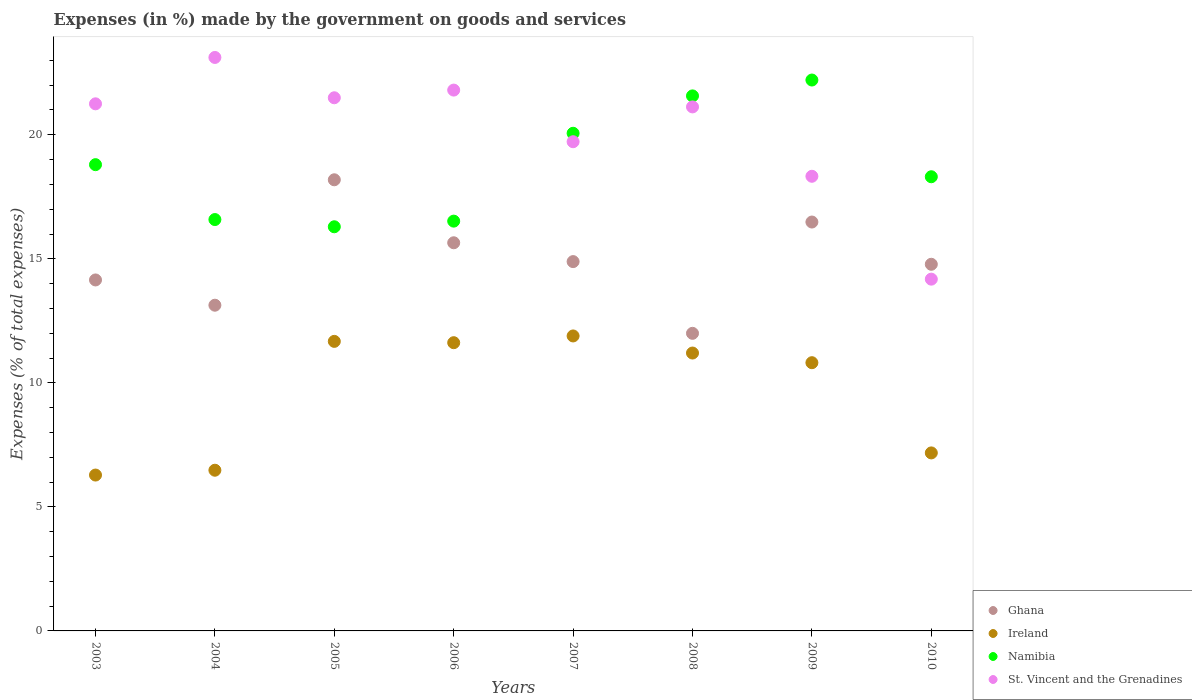How many different coloured dotlines are there?
Keep it short and to the point. 4. What is the percentage of expenses made by the government on goods and services in Namibia in 2007?
Provide a succinct answer. 20.06. Across all years, what is the maximum percentage of expenses made by the government on goods and services in Ireland?
Keep it short and to the point. 11.89. Across all years, what is the minimum percentage of expenses made by the government on goods and services in Ghana?
Make the answer very short. 12. In which year was the percentage of expenses made by the government on goods and services in Namibia maximum?
Your answer should be very brief. 2009. In which year was the percentage of expenses made by the government on goods and services in St. Vincent and the Grenadines minimum?
Offer a very short reply. 2010. What is the total percentage of expenses made by the government on goods and services in St. Vincent and the Grenadines in the graph?
Give a very brief answer. 161.01. What is the difference between the percentage of expenses made by the government on goods and services in Ghana in 2008 and that in 2009?
Provide a succinct answer. -4.49. What is the difference between the percentage of expenses made by the government on goods and services in Namibia in 2003 and the percentage of expenses made by the government on goods and services in Ireland in 2007?
Your answer should be compact. 6.9. What is the average percentage of expenses made by the government on goods and services in Ireland per year?
Offer a very short reply. 9.64. In the year 2008, what is the difference between the percentage of expenses made by the government on goods and services in Ireland and percentage of expenses made by the government on goods and services in Ghana?
Give a very brief answer. -0.79. What is the ratio of the percentage of expenses made by the government on goods and services in Ireland in 2004 to that in 2009?
Offer a very short reply. 0.6. Is the difference between the percentage of expenses made by the government on goods and services in Ireland in 2004 and 2007 greater than the difference between the percentage of expenses made by the government on goods and services in Ghana in 2004 and 2007?
Your answer should be compact. No. What is the difference between the highest and the second highest percentage of expenses made by the government on goods and services in Ghana?
Your answer should be very brief. 1.7. What is the difference between the highest and the lowest percentage of expenses made by the government on goods and services in Ghana?
Provide a succinct answer. 6.19. How many dotlines are there?
Your response must be concise. 4. How many years are there in the graph?
Ensure brevity in your answer.  8. Are the values on the major ticks of Y-axis written in scientific E-notation?
Ensure brevity in your answer.  No. Does the graph contain any zero values?
Offer a very short reply. No. Does the graph contain grids?
Your answer should be very brief. No. How many legend labels are there?
Keep it short and to the point. 4. What is the title of the graph?
Your answer should be very brief. Expenses (in %) made by the government on goods and services. What is the label or title of the Y-axis?
Provide a short and direct response. Expenses (% of total expenses). What is the Expenses (% of total expenses) of Ghana in 2003?
Offer a very short reply. 14.15. What is the Expenses (% of total expenses) of Ireland in 2003?
Your answer should be compact. 6.28. What is the Expenses (% of total expenses) in Namibia in 2003?
Your response must be concise. 18.8. What is the Expenses (% of total expenses) of St. Vincent and the Grenadines in 2003?
Provide a succinct answer. 21.25. What is the Expenses (% of total expenses) in Ghana in 2004?
Provide a short and direct response. 13.13. What is the Expenses (% of total expenses) in Ireland in 2004?
Give a very brief answer. 6.48. What is the Expenses (% of total expenses) in Namibia in 2004?
Your response must be concise. 16.58. What is the Expenses (% of total expenses) of St. Vincent and the Grenadines in 2004?
Offer a very short reply. 23.12. What is the Expenses (% of total expenses) in Ghana in 2005?
Offer a terse response. 18.19. What is the Expenses (% of total expenses) in Ireland in 2005?
Make the answer very short. 11.67. What is the Expenses (% of total expenses) of Namibia in 2005?
Your answer should be compact. 16.29. What is the Expenses (% of total expenses) of St. Vincent and the Grenadines in 2005?
Make the answer very short. 21.49. What is the Expenses (% of total expenses) of Ghana in 2006?
Offer a terse response. 15.65. What is the Expenses (% of total expenses) in Ireland in 2006?
Provide a succinct answer. 11.62. What is the Expenses (% of total expenses) in Namibia in 2006?
Your answer should be compact. 16.52. What is the Expenses (% of total expenses) of St. Vincent and the Grenadines in 2006?
Your answer should be very brief. 21.8. What is the Expenses (% of total expenses) of Ghana in 2007?
Make the answer very short. 14.89. What is the Expenses (% of total expenses) in Ireland in 2007?
Your answer should be very brief. 11.89. What is the Expenses (% of total expenses) of Namibia in 2007?
Keep it short and to the point. 20.06. What is the Expenses (% of total expenses) in St. Vincent and the Grenadines in 2007?
Offer a very short reply. 19.72. What is the Expenses (% of total expenses) of Ghana in 2008?
Your response must be concise. 12. What is the Expenses (% of total expenses) of Ireland in 2008?
Your answer should be compact. 11.2. What is the Expenses (% of total expenses) in Namibia in 2008?
Your response must be concise. 21.57. What is the Expenses (% of total expenses) of St. Vincent and the Grenadines in 2008?
Offer a very short reply. 21.12. What is the Expenses (% of total expenses) in Ghana in 2009?
Give a very brief answer. 16.48. What is the Expenses (% of total expenses) of Ireland in 2009?
Your response must be concise. 10.81. What is the Expenses (% of total expenses) of Namibia in 2009?
Your response must be concise. 22.21. What is the Expenses (% of total expenses) in St. Vincent and the Grenadines in 2009?
Your response must be concise. 18.33. What is the Expenses (% of total expenses) in Ghana in 2010?
Offer a very short reply. 14.78. What is the Expenses (% of total expenses) of Ireland in 2010?
Provide a short and direct response. 7.18. What is the Expenses (% of total expenses) of Namibia in 2010?
Your answer should be very brief. 18.31. What is the Expenses (% of total expenses) in St. Vincent and the Grenadines in 2010?
Your answer should be very brief. 14.18. Across all years, what is the maximum Expenses (% of total expenses) in Ghana?
Your response must be concise. 18.19. Across all years, what is the maximum Expenses (% of total expenses) in Ireland?
Give a very brief answer. 11.89. Across all years, what is the maximum Expenses (% of total expenses) in Namibia?
Make the answer very short. 22.21. Across all years, what is the maximum Expenses (% of total expenses) of St. Vincent and the Grenadines?
Your answer should be very brief. 23.12. Across all years, what is the minimum Expenses (% of total expenses) in Ghana?
Offer a terse response. 12. Across all years, what is the minimum Expenses (% of total expenses) of Ireland?
Offer a terse response. 6.28. Across all years, what is the minimum Expenses (% of total expenses) of Namibia?
Give a very brief answer. 16.29. Across all years, what is the minimum Expenses (% of total expenses) in St. Vincent and the Grenadines?
Your response must be concise. 14.18. What is the total Expenses (% of total expenses) in Ghana in the graph?
Ensure brevity in your answer.  119.26. What is the total Expenses (% of total expenses) of Ireland in the graph?
Provide a short and direct response. 77.13. What is the total Expenses (% of total expenses) of Namibia in the graph?
Provide a succinct answer. 150.33. What is the total Expenses (% of total expenses) in St. Vincent and the Grenadines in the graph?
Your response must be concise. 161.01. What is the difference between the Expenses (% of total expenses) of Ghana in 2003 and that in 2004?
Provide a succinct answer. 1.02. What is the difference between the Expenses (% of total expenses) of Ireland in 2003 and that in 2004?
Your answer should be compact. -0.19. What is the difference between the Expenses (% of total expenses) of Namibia in 2003 and that in 2004?
Give a very brief answer. 2.21. What is the difference between the Expenses (% of total expenses) of St. Vincent and the Grenadines in 2003 and that in 2004?
Your answer should be very brief. -1.87. What is the difference between the Expenses (% of total expenses) of Ghana in 2003 and that in 2005?
Make the answer very short. -4.04. What is the difference between the Expenses (% of total expenses) of Ireland in 2003 and that in 2005?
Provide a succinct answer. -5.39. What is the difference between the Expenses (% of total expenses) in Namibia in 2003 and that in 2005?
Offer a very short reply. 2.5. What is the difference between the Expenses (% of total expenses) of St. Vincent and the Grenadines in 2003 and that in 2005?
Your response must be concise. -0.24. What is the difference between the Expenses (% of total expenses) of Ghana in 2003 and that in 2006?
Offer a terse response. -1.5. What is the difference between the Expenses (% of total expenses) in Ireland in 2003 and that in 2006?
Ensure brevity in your answer.  -5.34. What is the difference between the Expenses (% of total expenses) in Namibia in 2003 and that in 2006?
Your response must be concise. 2.28. What is the difference between the Expenses (% of total expenses) in St. Vincent and the Grenadines in 2003 and that in 2006?
Offer a very short reply. -0.55. What is the difference between the Expenses (% of total expenses) of Ghana in 2003 and that in 2007?
Give a very brief answer. -0.74. What is the difference between the Expenses (% of total expenses) in Ireland in 2003 and that in 2007?
Give a very brief answer. -5.61. What is the difference between the Expenses (% of total expenses) in Namibia in 2003 and that in 2007?
Your response must be concise. -1.27. What is the difference between the Expenses (% of total expenses) of St. Vincent and the Grenadines in 2003 and that in 2007?
Your response must be concise. 1.53. What is the difference between the Expenses (% of total expenses) in Ghana in 2003 and that in 2008?
Provide a succinct answer. 2.15. What is the difference between the Expenses (% of total expenses) of Ireland in 2003 and that in 2008?
Offer a terse response. -4.92. What is the difference between the Expenses (% of total expenses) in Namibia in 2003 and that in 2008?
Your response must be concise. -2.77. What is the difference between the Expenses (% of total expenses) of St. Vincent and the Grenadines in 2003 and that in 2008?
Give a very brief answer. 0.12. What is the difference between the Expenses (% of total expenses) of Ghana in 2003 and that in 2009?
Provide a short and direct response. -2.33. What is the difference between the Expenses (% of total expenses) in Ireland in 2003 and that in 2009?
Keep it short and to the point. -4.53. What is the difference between the Expenses (% of total expenses) of Namibia in 2003 and that in 2009?
Your answer should be compact. -3.41. What is the difference between the Expenses (% of total expenses) of St. Vincent and the Grenadines in 2003 and that in 2009?
Offer a very short reply. 2.92. What is the difference between the Expenses (% of total expenses) of Ghana in 2003 and that in 2010?
Make the answer very short. -0.63. What is the difference between the Expenses (% of total expenses) of Ireland in 2003 and that in 2010?
Your answer should be compact. -0.89. What is the difference between the Expenses (% of total expenses) of Namibia in 2003 and that in 2010?
Provide a succinct answer. 0.49. What is the difference between the Expenses (% of total expenses) of St. Vincent and the Grenadines in 2003 and that in 2010?
Give a very brief answer. 7.07. What is the difference between the Expenses (% of total expenses) of Ghana in 2004 and that in 2005?
Give a very brief answer. -5.06. What is the difference between the Expenses (% of total expenses) in Ireland in 2004 and that in 2005?
Offer a terse response. -5.19. What is the difference between the Expenses (% of total expenses) of Namibia in 2004 and that in 2005?
Offer a terse response. 0.29. What is the difference between the Expenses (% of total expenses) of St. Vincent and the Grenadines in 2004 and that in 2005?
Offer a terse response. 1.63. What is the difference between the Expenses (% of total expenses) of Ghana in 2004 and that in 2006?
Make the answer very short. -2.52. What is the difference between the Expenses (% of total expenses) in Ireland in 2004 and that in 2006?
Provide a short and direct response. -5.14. What is the difference between the Expenses (% of total expenses) in Namibia in 2004 and that in 2006?
Provide a succinct answer. 0.06. What is the difference between the Expenses (% of total expenses) in St. Vincent and the Grenadines in 2004 and that in 2006?
Ensure brevity in your answer.  1.32. What is the difference between the Expenses (% of total expenses) of Ghana in 2004 and that in 2007?
Ensure brevity in your answer.  -1.76. What is the difference between the Expenses (% of total expenses) in Ireland in 2004 and that in 2007?
Make the answer very short. -5.41. What is the difference between the Expenses (% of total expenses) in Namibia in 2004 and that in 2007?
Keep it short and to the point. -3.48. What is the difference between the Expenses (% of total expenses) in St. Vincent and the Grenadines in 2004 and that in 2007?
Your response must be concise. 3.4. What is the difference between the Expenses (% of total expenses) of Ghana in 2004 and that in 2008?
Your response must be concise. 1.13. What is the difference between the Expenses (% of total expenses) in Ireland in 2004 and that in 2008?
Give a very brief answer. -4.72. What is the difference between the Expenses (% of total expenses) of Namibia in 2004 and that in 2008?
Keep it short and to the point. -4.98. What is the difference between the Expenses (% of total expenses) of St. Vincent and the Grenadines in 2004 and that in 2008?
Offer a very short reply. 1.99. What is the difference between the Expenses (% of total expenses) in Ghana in 2004 and that in 2009?
Provide a succinct answer. -3.35. What is the difference between the Expenses (% of total expenses) in Ireland in 2004 and that in 2009?
Make the answer very short. -4.33. What is the difference between the Expenses (% of total expenses) of Namibia in 2004 and that in 2009?
Give a very brief answer. -5.62. What is the difference between the Expenses (% of total expenses) in St. Vincent and the Grenadines in 2004 and that in 2009?
Your response must be concise. 4.79. What is the difference between the Expenses (% of total expenses) of Ghana in 2004 and that in 2010?
Give a very brief answer. -1.65. What is the difference between the Expenses (% of total expenses) of Ireland in 2004 and that in 2010?
Your answer should be compact. -0.7. What is the difference between the Expenses (% of total expenses) in Namibia in 2004 and that in 2010?
Give a very brief answer. -1.73. What is the difference between the Expenses (% of total expenses) in St. Vincent and the Grenadines in 2004 and that in 2010?
Make the answer very short. 8.94. What is the difference between the Expenses (% of total expenses) in Ghana in 2005 and that in 2006?
Give a very brief answer. 2.54. What is the difference between the Expenses (% of total expenses) in Ireland in 2005 and that in 2006?
Provide a succinct answer. 0.05. What is the difference between the Expenses (% of total expenses) of Namibia in 2005 and that in 2006?
Make the answer very short. -0.23. What is the difference between the Expenses (% of total expenses) in St. Vincent and the Grenadines in 2005 and that in 2006?
Offer a very short reply. -0.31. What is the difference between the Expenses (% of total expenses) in Ghana in 2005 and that in 2007?
Your answer should be compact. 3.3. What is the difference between the Expenses (% of total expenses) in Ireland in 2005 and that in 2007?
Make the answer very short. -0.22. What is the difference between the Expenses (% of total expenses) of Namibia in 2005 and that in 2007?
Your answer should be compact. -3.77. What is the difference between the Expenses (% of total expenses) in St. Vincent and the Grenadines in 2005 and that in 2007?
Your answer should be very brief. 1.77. What is the difference between the Expenses (% of total expenses) in Ghana in 2005 and that in 2008?
Offer a terse response. 6.19. What is the difference between the Expenses (% of total expenses) in Ireland in 2005 and that in 2008?
Your answer should be very brief. 0.47. What is the difference between the Expenses (% of total expenses) of Namibia in 2005 and that in 2008?
Your answer should be compact. -5.28. What is the difference between the Expenses (% of total expenses) of St. Vincent and the Grenadines in 2005 and that in 2008?
Your answer should be very brief. 0.37. What is the difference between the Expenses (% of total expenses) of Ghana in 2005 and that in 2009?
Offer a very short reply. 1.7. What is the difference between the Expenses (% of total expenses) in Ireland in 2005 and that in 2009?
Ensure brevity in your answer.  0.86. What is the difference between the Expenses (% of total expenses) in Namibia in 2005 and that in 2009?
Offer a terse response. -5.92. What is the difference between the Expenses (% of total expenses) of St. Vincent and the Grenadines in 2005 and that in 2009?
Offer a terse response. 3.17. What is the difference between the Expenses (% of total expenses) in Ghana in 2005 and that in 2010?
Provide a succinct answer. 3.41. What is the difference between the Expenses (% of total expenses) of Ireland in 2005 and that in 2010?
Keep it short and to the point. 4.5. What is the difference between the Expenses (% of total expenses) in Namibia in 2005 and that in 2010?
Give a very brief answer. -2.02. What is the difference between the Expenses (% of total expenses) of St. Vincent and the Grenadines in 2005 and that in 2010?
Your answer should be very brief. 7.31. What is the difference between the Expenses (% of total expenses) of Ghana in 2006 and that in 2007?
Your answer should be compact. 0.76. What is the difference between the Expenses (% of total expenses) of Ireland in 2006 and that in 2007?
Your answer should be very brief. -0.27. What is the difference between the Expenses (% of total expenses) of Namibia in 2006 and that in 2007?
Your answer should be compact. -3.54. What is the difference between the Expenses (% of total expenses) in St. Vincent and the Grenadines in 2006 and that in 2007?
Give a very brief answer. 2.08. What is the difference between the Expenses (% of total expenses) in Ghana in 2006 and that in 2008?
Your answer should be very brief. 3.65. What is the difference between the Expenses (% of total expenses) of Ireland in 2006 and that in 2008?
Your answer should be very brief. 0.42. What is the difference between the Expenses (% of total expenses) in Namibia in 2006 and that in 2008?
Provide a succinct answer. -5.05. What is the difference between the Expenses (% of total expenses) in St. Vincent and the Grenadines in 2006 and that in 2008?
Your response must be concise. 0.68. What is the difference between the Expenses (% of total expenses) in Ghana in 2006 and that in 2009?
Ensure brevity in your answer.  -0.84. What is the difference between the Expenses (% of total expenses) in Ireland in 2006 and that in 2009?
Provide a short and direct response. 0.81. What is the difference between the Expenses (% of total expenses) in Namibia in 2006 and that in 2009?
Keep it short and to the point. -5.69. What is the difference between the Expenses (% of total expenses) of St. Vincent and the Grenadines in 2006 and that in 2009?
Keep it short and to the point. 3.47. What is the difference between the Expenses (% of total expenses) in Ghana in 2006 and that in 2010?
Keep it short and to the point. 0.87. What is the difference between the Expenses (% of total expenses) in Ireland in 2006 and that in 2010?
Give a very brief answer. 4.44. What is the difference between the Expenses (% of total expenses) of Namibia in 2006 and that in 2010?
Your response must be concise. -1.79. What is the difference between the Expenses (% of total expenses) in St. Vincent and the Grenadines in 2006 and that in 2010?
Give a very brief answer. 7.62. What is the difference between the Expenses (% of total expenses) in Ghana in 2007 and that in 2008?
Make the answer very short. 2.89. What is the difference between the Expenses (% of total expenses) in Ireland in 2007 and that in 2008?
Your answer should be very brief. 0.69. What is the difference between the Expenses (% of total expenses) of Namibia in 2007 and that in 2008?
Your response must be concise. -1.51. What is the difference between the Expenses (% of total expenses) of St. Vincent and the Grenadines in 2007 and that in 2008?
Provide a short and direct response. -1.4. What is the difference between the Expenses (% of total expenses) in Ghana in 2007 and that in 2009?
Give a very brief answer. -1.6. What is the difference between the Expenses (% of total expenses) of Ireland in 2007 and that in 2009?
Ensure brevity in your answer.  1.08. What is the difference between the Expenses (% of total expenses) of Namibia in 2007 and that in 2009?
Your response must be concise. -2.15. What is the difference between the Expenses (% of total expenses) in St. Vincent and the Grenadines in 2007 and that in 2009?
Make the answer very short. 1.39. What is the difference between the Expenses (% of total expenses) in Ghana in 2007 and that in 2010?
Offer a very short reply. 0.11. What is the difference between the Expenses (% of total expenses) of Ireland in 2007 and that in 2010?
Offer a very short reply. 4.71. What is the difference between the Expenses (% of total expenses) in Namibia in 2007 and that in 2010?
Provide a short and direct response. 1.75. What is the difference between the Expenses (% of total expenses) of St. Vincent and the Grenadines in 2007 and that in 2010?
Your response must be concise. 5.54. What is the difference between the Expenses (% of total expenses) in Ghana in 2008 and that in 2009?
Your answer should be compact. -4.49. What is the difference between the Expenses (% of total expenses) of Ireland in 2008 and that in 2009?
Give a very brief answer. 0.39. What is the difference between the Expenses (% of total expenses) in Namibia in 2008 and that in 2009?
Make the answer very short. -0.64. What is the difference between the Expenses (% of total expenses) in St. Vincent and the Grenadines in 2008 and that in 2009?
Provide a short and direct response. 2.8. What is the difference between the Expenses (% of total expenses) in Ghana in 2008 and that in 2010?
Provide a succinct answer. -2.78. What is the difference between the Expenses (% of total expenses) in Ireland in 2008 and that in 2010?
Your answer should be very brief. 4.03. What is the difference between the Expenses (% of total expenses) in Namibia in 2008 and that in 2010?
Make the answer very short. 3.26. What is the difference between the Expenses (% of total expenses) in St. Vincent and the Grenadines in 2008 and that in 2010?
Keep it short and to the point. 6.94. What is the difference between the Expenses (% of total expenses) in Ghana in 2009 and that in 2010?
Offer a very short reply. 1.7. What is the difference between the Expenses (% of total expenses) of Ireland in 2009 and that in 2010?
Provide a short and direct response. 3.64. What is the difference between the Expenses (% of total expenses) of Namibia in 2009 and that in 2010?
Offer a very short reply. 3.9. What is the difference between the Expenses (% of total expenses) in St. Vincent and the Grenadines in 2009 and that in 2010?
Provide a succinct answer. 4.15. What is the difference between the Expenses (% of total expenses) in Ghana in 2003 and the Expenses (% of total expenses) in Ireland in 2004?
Your answer should be very brief. 7.67. What is the difference between the Expenses (% of total expenses) of Ghana in 2003 and the Expenses (% of total expenses) of Namibia in 2004?
Provide a succinct answer. -2.43. What is the difference between the Expenses (% of total expenses) of Ghana in 2003 and the Expenses (% of total expenses) of St. Vincent and the Grenadines in 2004?
Your answer should be compact. -8.97. What is the difference between the Expenses (% of total expenses) of Ireland in 2003 and the Expenses (% of total expenses) of Namibia in 2004?
Offer a very short reply. -10.3. What is the difference between the Expenses (% of total expenses) of Ireland in 2003 and the Expenses (% of total expenses) of St. Vincent and the Grenadines in 2004?
Keep it short and to the point. -16.83. What is the difference between the Expenses (% of total expenses) in Namibia in 2003 and the Expenses (% of total expenses) in St. Vincent and the Grenadines in 2004?
Offer a very short reply. -4.32. What is the difference between the Expenses (% of total expenses) of Ghana in 2003 and the Expenses (% of total expenses) of Ireland in 2005?
Give a very brief answer. 2.48. What is the difference between the Expenses (% of total expenses) of Ghana in 2003 and the Expenses (% of total expenses) of Namibia in 2005?
Keep it short and to the point. -2.14. What is the difference between the Expenses (% of total expenses) of Ghana in 2003 and the Expenses (% of total expenses) of St. Vincent and the Grenadines in 2005?
Your answer should be compact. -7.34. What is the difference between the Expenses (% of total expenses) of Ireland in 2003 and the Expenses (% of total expenses) of Namibia in 2005?
Ensure brevity in your answer.  -10.01. What is the difference between the Expenses (% of total expenses) in Ireland in 2003 and the Expenses (% of total expenses) in St. Vincent and the Grenadines in 2005?
Make the answer very short. -15.21. What is the difference between the Expenses (% of total expenses) in Namibia in 2003 and the Expenses (% of total expenses) in St. Vincent and the Grenadines in 2005?
Your response must be concise. -2.7. What is the difference between the Expenses (% of total expenses) in Ghana in 2003 and the Expenses (% of total expenses) in Ireland in 2006?
Give a very brief answer. 2.53. What is the difference between the Expenses (% of total expenses) of Ghana in 2003 and the Expenses (% of total expenses) of Namibia in 2006?
Your answer should be very brief. -2.37. What is the difference between the Expenses (% of total expenses) in Ghana in 2003 and the Expenses (% of total expenses) in St. Vincent and the Grenadines in 2006?
Your answer should be very brief. -7.65. What is the difference between the Expenses (% of total expenses) of Ireland in 2003 and the Expenses (% of total expenses) of Namibia in 2006?
Ensure brevity in your answer.  -10.24. What is the difference between the Expenses (% of total expenses) in Ireland in 2003 and the Expenses (% of total expenses) in St. Vincent and the Grenadines in 2006?
Make the answer very short. -15.52. What is the difference between the Expenses (% of total expenses) in Namibia in 2003 and the Expenses (% of total expenses) in St. Vincent and the Grenadines in 2006?
Provide a short and direct response. -3.01. What is the difference between the Expenses (% of total expenses) in Ghana in 2003 and the Expenses (% of total expenses) in Ireland in 2007?
Your answer should be compact. 2.26. What is the difference between the Expenses (% of total expenses) of Ghana in 2003 and the Expenses (% of total expenses) of Namibia in 2007?
Your response must be concise. -5.91. What is the difference between the Expenses (% of total expenses) in Ghana in 2003 and the Expenses (% of total expenses) in St. Vincent and the Grenadines in 2007?
Your answer should be compact. -5.57. What is the difference between the Expenses (% of total expenses) in Ireland in 2003 and the Expenses (% of total expenses) in Namibia in 2007?
Offer a very short reply. -13.78. What is the difference between the Expenses (% of total expenses) in Ireland in 2003 and the Expenses (% of total expenses) in St. Vincent and the Grenadines in 2007?
Give a very brief answer. -13.44. What is the difference between the Expenses (% of total expenses) in Namibia in 2003 and the Expenses (% of total expenses) in St. Vincent and the Grenadines in 2007?
Keep it short and to the point. -0.92. What is the difference between the Expenses (% of total expenses) in Ghana in 2003 and the Expenses (% of total expenses) in Ireland in 2008?
Your response must be concise. 2.95. What is the difference between the Expenses (% of total expenses) of Ghana in 2003 and the Expenses (% of total expenses) of Namibia in 2008?
Offer a very short reply. -7.42. What is the difference between the Expenses (% of total expenses) of Ghana in 2003 and the Expenses (% of total expenses) of St. Vincent and the Grenadines in 2008?
Provide a succinct answer. -6.98. What is the difference between the Expenses (% of total expenses) of Ireland in 2003 and the Expenses (% of total expenses) of Namibia in 2008?
Offer a very short reply. -15.28. What is the difference between the Expenses (% of total expenses) in Ireland in 2003 and the Expenses (% of total expenses) in St. Vincent and the Grenadines in 2008?
Ensure brevity in your answer.  -14.84. What is the difference between the Expenses (% of total expenses) of Namibia in 2003 and the Expenses (% of total expenses) of St. Vincent and the Grenadines in 2008?
Offer a terse response. -2.33. What is the difference between the Expenses (% of total expenses) in Ghana in 2003 and the Expenses (% of total expenses) in Ireland in 2009?
Keep it short and to the point. 3.34. What is the difference between the Expenses (% of total expenses) of Ghana in 2003 and the Expenses (% of total expenses) of Namibia in 2009?
Ensure brevity in your answer.  -8.06. What is the difference between the Expenses (% of total expenses) in Ghana in 2003 and the Expenses (% of total expenses) in St. Vincent and the Grenadines in 2009?
Your response must be concise. -4.18. What is the difference between the Expenses (% of total expenses) of Ireland in 2003 and the Expenses (% of total expenses) of Namibia in 2009?
Your response must be concise. -15.92. What is the difference between the Expenses (% of total expenses) of Ireland in 2003 and the Expenses (% of total expenses) of St. Vincent and the Grenadines in 2009?
Offer a terse response. -12.04. What is the difference between the Expenses (% of total expenses) of Namibia in 2003 and the Expenses (% of total expenses) of St. Vincent and the Grenadines in 2009?
Your answer should be compact. 0.47. What is the difference between the Expenses (% of total expenses) in Ghana in 2003 and the Expenses (% of total expenses) in Ireland in 2010?
Make the answer very short. 6.97. What is the difference between the Expenses (% of total expenses) of Ghana in 2003 and the Expenses (% of total expenses) of Namibia in 2010?
Ensure brevity in your answer.  -4.16. What is the difference between the Expenses (% of total expenses) in Ghana in 2003 and the Expenses (% of total expenses) in St. Vincent and the Grenadines in 2010?
Your response must be concise. -0.03. What is the difference between the Expenses (% of total expenses) in Ireland in 2003 and the Expenses (% of total expenses) in Namibia in 2010?
Make the answer very short. -12.02. What is the difference between the Expenses (% of total expenses) of Ireland in 2003 and the Expenses (% of total expenses) of St. Vincent and the Grenadines in 2010?
Provide a succinct answer. -7.9. What is the difference between the Expenses (% of total expenses) of Namibia in 2003 and the Expenses (% of total expenses) of St. Vincent and the Grenadines in 2010?
Give a very brief answer. 4.62. What is the difference between the Expenses (% of total expenses) of Ghana in 2004 and the Expenses (% of total expenses) of Ireland in 2005?
Your response must be concise. 1.46. What is the difference between the Expenses (% of total expenses) of Ghana in 2004 and the Expenses (% of total expenses) of Namibia in 2005?
Your answer should be compact. -3.16. What is the difference between the Expenses (% of total expenses) of Ghana in 2004 and the Expenses (% of total expenses) of St. Vincent and the Grenadines in 2005?
Your answer should be compact. -8.36. What is the difference between the Expenses (% of total expenses) in Ireland in 2004 and the Expenses (% of total expenses) in Namibia in 2005?
Ensure brevity in your answer.  -9.81. What is the difference between the Expenses (% of total expenses) in Ireland in 2004 and the Expenses (% of total expenses) in St. Vincent and the Grenadines in 2005?
Your answer should be compact. -15.01. What is the difference between the Expenses (% of total expenses) in Namibia in 2004 and the Expenses (% of total expenses) in St. Vincent and the Grenadines in 2005?
Your answer should be compact. -4.91. What is the difference between the Expenses (% of total expenses) in Ghana in 2004 and the Expenses (% of total expenses) in Ireland in 2006?
Ensure brevity in your answer.  1.51. What is the difference between the Expenses (% of total expenses) of Ghana in 2004 and the Expenses (% of total expenses) of Namibia in 2006?
Provide a short and direct response. -3.39. What is the difference between the Expenses (% of total expenses) in Ghana in 2004 and the Expenses (% of total expenses) in St. Vincent and the Grenadines in 2006?
Your answer should be compact. -8.67. What is the difference between the Expenses (% of total expenses) of Ireland in 2004 and the Expenses (% of total expenses) of Namibia in 2006?
Your response must be concise. -10.04. What is the difference between the Expenses (% of total expenses) in Ireland in 2004 and the Expenses (% of total expenses) in St. Vincent and the Grenadines in 2006?
Your answer should be very brief. -15.32. What is the difference between the Expenses (% of total expenses) in Namibia in 2004 and the Expenses (% of total expenses) in St. Vincent and the Grenadines in 2006?
Give a very brief answer. -5.22. What is the difference between the Expenses (% of total expenses) in Ghana in 2004 and the Expenses (% of total expenses) in Ireland in 2007?
Make the answer very short. 1.24. What is the difference between the Expenses (% of total expenses) of Ghana in 2004 and the Expenses (% of total expenses) of Namibia in 2007?
Offer a very short reply. -6.93. What is the difference between the Expenses (% of total expenses) of Ghana in 2004 and the Expenses (% of total expenses) of St. Vincent and the Grenadines in 2007?
Offer a very short reply. -6.59. What is the difference between the Expenses (% of total expenses) in Ireland in 2004 and the Expenses (% of total expenses) in Namibia in 2007?
Your answer should be compact. -13.58. What is the difference between the Expenses (% of total expenses) in Ireland in 2004 and the Expenses (% of total expenses) in St. Vincent and the Grenadines in 2007?
Keep it short and to the point. -13.24. What is the difference between the Expenses (% of total expenses) in Namibia in 2004 and the Expenses (% of total expenses) in St. Vincent and the Grenadines in 2007?
Your answer should be very brief. -3.14. What is the difference between the Expenses (% of total expenses) in Ghana in 2004 and the Expenses (% of total expenses) in Ireland in 2008?
Provide a succinct answer. 1.93. What is the difference between the Expenses (% of total expenses) in Ghana in 2004 and the Expenses (% of total expenses) in Namibia in 2008?
Ensure brevity in your answer.  -8.44. What is the difference between the Expenses (% of total expenses) in Ghana in 2004 and the Expenses (% of total expenses) in St. Vincent and the Grenadines in 2008?
Provide a succinct answer. -7.99. What is the difference between the Expenses (% of total expenses) of Ireland in 2004 and the Expenses (% of total expenses) of Namibia in 2008?
Your answer should be very brief. -15.09. What is the difference between the Expenses (% of total expenses) in Ireland in 2004 and the Expenses (% of total expenses) in St. Vincent and the Grenadines in 2008?
Ensure brevity in your answer.  -14.65. What is the difference between the Expenses (% of total expenses) of Namibia in 2004 and the Expenses (% of total expenses) of St. Vincent and the Grenadines in 2008?
Provide a short and direct response. -4.54. What is the difference between the Expenses (% of total expenses) of Ghana in 2004 and the Expenses (% of total expenses) of Ireland in 2009?
Make the answer very short. 2.32. What is the difference between the Expenses (% of total expenses) in Ghana in 2004 and the Expenses (% of total expenses) in Namibia in 2009?
Make the answer very short. -9.08. What is the difference between the Expenses (% of total expenses) of Ghana in 2004 and the Expenses (% of total expenses) of St. Vincent and the Grenadines in 2009?
Provide a short and direct response. -5.2. What is the difference between the Expenses (% of total expenses) in Ireland in 2004 and the Expenses (% of total expenses) in Namibia in 2009?
Make the answer very short. -15.73. What is the difference between the Expenses (% of total expenses) of Ireland in 2004 and the Expenses (% of total expenses) of St. Vincent and the Grenadines in 2009?
Offer a terse response. -11.85. What is the difference between the Expenses (% of total expenses) in Namibia in 2004 and the Expenses (% of total expenses) in St. Vincent and the Grenadines in 2009?
Ensure brevity in your answer.  -1.74. What is the difference between the Expenses (% of total expenses) of Ghana in 2004 and the Expenses (% of total expenses) of Ireland in 2010?
Give a very brief answer. 5.95. What is the difference between the Expenses (% of total expenses) in Ghana in 2004 and the Expenses (% of total expenses) in Namibia in 2010?
Make the answer very short. -5.18. What is the difference between the Expenses (% of total expenses) in Ghana in 2004 and the Expenses (% of total expenses) in St. Vincent and the Grenadines in 2010?
Ensure brevity in your answer.  -1.05. What is the difference between the Expenses (% of total expenses) in Ireland in 2004 and the Expenses (% of total expenses) in Namibia in 2010?
Make the answer very short. -11.83. What is the difference between the Expenses (% of total expenses) in Ireland in 2004 and the Expenses (% of total expenses) in St. Vincent and the Grenadines in 2010?
Offer a very short reply. -7.7. What is the difference between the Expenses (% of total expenses) in Namibia in 2004 and the Expenses (% of total expenses) in St. Vincent and the Grenadines in 2010?
Your answer should be very brief. 2.4. What is the difference between the Expenses (% of total expenses) in Ghana in 2005 and the Expenses (% of total expenses) in Ireland in 2006?
Ensure brevity in your answer.  6.57. What is the difference between the Expenses (% of total expenses) of Ghana in 2005 and the Expenses (% of total expenses) of Namibia in 2006?
Keep it short and to the point. 1.67. What is the difference between the Expenses (% of total expenses) of Ghana in 2005 and the Expenses (% of total expenses) of St. Vincent and the Grenadines in 2006?
Keep it short and to the point. -3.62. What is the difference between the Expenses (% of total expenses) in Ireland in 2005 and the Expenses (% of total expenses) in Namibia in 2006?
Offer a terse response. -4.85. What is the difference between the Expenses (% of total expenses) in Ireland in 2005 and the Expenses (% of total expenses) in St. Vincent and the Grenadines in 2006?
Give a very brief answer. -10.13. What is the difference between the Expenses (% of total expenses) in Namibia in 2005 and the Expenses (% of total expenses) in St. Vincent and the Grenadines in 2006?
Offer a very short reply. -5.51. What is the difference between the Expenses (% of total expenses) of Ghana in 2005 and the Expenses (% of total expenses) of Ireland in 2007?
Provide a short and direct response. 6.29. What is the difference between the Expenses (% of total expenses) of Ghana in 2005 and the Expenses (% of total expenses) of Namibia in 2007?
Keep it short and to the point. -1.88. What is the difference between the Expenses (% of total expenses) in Ghana in 2005 and the Expenses (% of total expenses) in St. Vincent and the Grenadines in 2007?
Offer a terse response. -1.53. What is the difference between the Expenses (% of total expenses) in Ireland in 2005 and the Expenses (% of total expenses) in Namibia in 2007?
Provide a short and direct response. -8.39. What is the difference between the Expenses (% of total expenses) of Ireland in 2005 and the Expenses (% of total expenses) of St. Vincent and the Grenadines in 2007?
Your answer should be compact. -8.05. What is the difference between the Expenses (% of total expenses) of Namibia in 2005 and the Expenses (% of total expenses) of St. Vincent and the Grenadines in 2007?
Offer a terse response. -3.43. What is the difference between the Expenses (% of total expenses) of Ghana in 2005 and the Expenses (% of total expenses) of Ireland in 2008?
Keep it short and to the point. 6.98. What is the difference between the Expenses (% of total expenses) of Ghana in 2005 and the Expenses (% of total expenses) of Namibia in 2008?
Provide a succinct answer. -3.38. What is the difference between the Expenses (% of total expenses) of Ghana in 2005 and the Expenses (% of total expenses) of St. Vincent and the Grenadines in 2008?
Provide a succinct answer. -2.94. What is the difference between the Expenses (% of total expenses) of Ireland in 2005 and the Expenses (% of total expenses) of Namibia in 2008?
Provide a short and direct response. -9.9. What is the difference between the Expenses (% of total expenses) in Ireland in 2005 and the Expenses (% of total expenses) in St. Vincent and the Grenadines in 2008?
Give a very brief answer. -9.45. What is the difference between the Expenses (% of total expenses) of Namibia in 2005 and the Expenses (% of total expenses) of St. Vincent and the Grenadines in 2008?
Make the answer very short. -4.83. What is the difference between the Expenses (% of total expenses) in Ghana in 2005 and the Expenses (% of total expenses) in Ireland in 2009?
Keep it short and to the point. 7.37. What is the difference between the Expenses (% of total expenses) of Ghana in 2005 and the Expenses (% of total expenses) of Namibia in 2009?
Your response must be concise. -4.02. What is the difference between the Expenses (% of total expenses) of Ghana in 2005 and the Expenses (% of total expenses) of St. Vincent and the Grenadines in 2009?
Your answer should be very brief. -0.14. What is the difference between the Expenses (% of total expenses) in Ireland in 2005 and the Expenses (% of total expenses) in Namibia in 2009?
Your answer should be compact. -10.54. What is the difference between the Expenses (% of total expenses) in Ireland in 2005 and the Expenses (% of total expenses) in St. Vincent and the Grenadines in 2009?
Ensure brevity in your answer.  -6.66. What is the difference between the Expenses (% of total expenses) of Namibia in 2005 and the Expenses (% of total expenses) of St. Vincent and the Grenadines in 2009?
Make the answer very short. -2.04. What is the difference between the Expenses (% of total expenses) in Ghana in 2005 and the Expenses (% of total expenses) in Ireland in 2010?
Offer a terse response. 11.01. What is the difference between the Expenses (% of total expenses) in Ghana in 2005 and the Expenses (% of total expenses) in Namibia in 2010?
Your response must be concise. -0.12. What is the difference between the Expenses (% of total expenses) of Ghana in 2005 and the Expenses (% of total expenses) of St. Vincent and the Grenadines in 2010?
Make the answer very short. 4.01. What is the difference between the Expenses (% of total expenses) in Ireland in 2005 and the Expenses (% of total expenses) in Namibia in 2010?
Your response must be concise. -6.64. What is the difference between the Expenses (% of total expenses) of Ireland in 2005 and the Expenses (% of total expenses) of St. Vincent and the Grenadines in 2010?
Keep it short and to the point. -2.51. What is the difference between the Expenses (% of total expenses) of Namibia in 2005 and the Expenses (% of total expenses) of St. Vincent and the Grenadines in 2010?
Your answer should be very brief. 2.11. What is the difference between the Expenses (% of total expenses) in Ghana in 2006 and the Expenses (% of total expenses) in Ireland in 2007?
Your answer should be very brief. 3.76. What is the difference between the Expenses (% of total expenses) of Ghana in 2006 and the Expenses (% of total expenses) of Namibia in 2007?
Ensure brevity in your answer.  -4.41. What is the difference between the Expenses (% of total expenses) of Ghana in 2006 and the Expenses (% of total expenses) of St. Vincent and the Grenadines in 2007?
Give a very brief answer. -4.07. What is the difference between the Expenses (% of total expenses) of Ireland in 2006 and the Expenses (% of total expenses) of Namibia in 2007?
Make the answer very short. -8.44. What is the difference between the Expenses (% of total expenses) of Ireland in 2006 and the Expenses (% of total expenses) of St. Vincent and the Grenadines in 2007?
Provide a succinct answer. -8.1. What is the difference between the Expenses (% of total expenses) in Namibia in 2006 and the Expenses (% of total expenses) in St. Vincent and the Grenadines in 2007?
Offer a terse response. -3.2. What is the difference between the Expenses (% of total expenses) in Ghana in 2006 and the Expenses (% of total expenses) in Ireland in 2008?
Make the answer very short. 4.44. What is the difference between the Expenses (% of total expenses) of Ghana in 2006 and the Expenses (% of total expenses) of Namibia in 2008?
Your answer should be compact. -5.92. What is the difference between the Expenses (% of total expenses) in Ghana in 2006 and the Expenses (% of total expenses) in St. Vincent and the Grenadines in 2008?
Your answer should be very brief. -5.48. What is the difference between the Expenses (% of total expenses) in Ireland in 2006 and the Expenses (% of total expenses) in Namibia in 2008?
Offer a very short reply. -9.95. What is the difference between the Expenses (% of total expenses) in Ireland in 2006 and the Expenses (% of total expenses) in St. Vincent and the Grenadines in 2008?
Provide a succinct answer. -9.5. What is the difference between the Expenses (% of total expenses) of Namibia in 2006 and the Expenses (% of total expenses) of St. Vincent and the Grenadines in 2008?
Keep it short and to the point. -4.6. What is the difference between the Expenses (% of total expenses) in Ghana in 2006 and the Expenses (% of total expenses) in Ireland in 2009?
Offer a terse response. 4.83. What is the difference between the Expenses (% of total expenses) in Ghana in 2006 and the Expenses (% of total expenses) in Namibia in 2009?
Provide a succinct answer. -6.56. What is the difference between the Expenses (% of total expenses) of Ghana in 2006 and the Expenses (% of total expenses) of St. Vincent and the Grenadines in 2009?
Your answer should be compact. -2.68. What is the difference between the Expenses (% of total expenses) of Ireland in 2006 and the Expenses (% of total expenses) of Namibia in 2009?
Your response must be concise. -10.59. What is the difference between the Expenses (% of total expenses) of Ireland in 2006 and the Expenses (% of total expenses) of St. Vincent and the Grenadines in 2009?
Provide a short and direct response. -6.71. What is the difference between the Expenses (% of total expenses) of Namibia in 2006 and the Expenses (% of total expenses) of St. Vincent and the Grenadines in 2009?
Offer a very short reply. -1.81. What is the difference between the Expenses (% of total expenses) of Ghana in 2006 and the Expenses (% of total expenses) of Ireland in 2010?
Ensure brevity in your answer.  8.47. What is the difference between the Expenses (% of total expenses) in Ghana in 2006 and the Expenses (% of total expenses) in Namibia in 2010?
Provide a short and direct response. -2.66. What is the difference between the Expenses (% of total expenses) of Ghana in 2006 and the Expenses (% of total expenses) of St. Vincent and the Grenadines in 2010?
Your answer should be very brief. 1.47. What is the difference between the Expenses (% of total expenses) of Ireland in 2006 and the Expenses (% of total expenses) of Namibia in 2010?
Your answer should be compact. -6.69. What is the difference between the Expenses (% of total expenses) in Ireland in 2006 and the Expenses (% of total expenses) in St. Vincent and the Grenadines in 2010?
Offer a terse response. -2.56. What is the difference between the Expenses (% of total expenses) in Namibia in 2006 and the Expenses (% of total expenses) in St. Vincent and the Grenadines in 2010?
Provide a short and direct response. 2.34. What is the difference between the Expenses (% of total expenses) in Ghana in 2007 and the Expenses (% of total expenses) in Ireland in 2008?
Keep it short and to the point. 3.69. What is the difference between the Expenses (% of total expenses) in Ghana in 2007 and the Expenses (% of total expenses) in Namibia in 2008?
Ensure brevity in your answer.  -6.68. What is the difference between the Expenses (% of total expenses) of Ghana in 2007 and the Expenses (% of total expenses) of St. Vincent and the Grenadines in 2008?
Your answer should be very brief. -6.24. What is the difference between the Expenses (% of total expenses) of Ireland in 2007 and the Expenses (% of total expenses) of Namibia in 2008?
Ensure brevity in your answer.  -9.68. What is the difference between the Expenses (% of total expenses) in Ireland in 2007 and the Expenses (% of total expenses) in St. Vincent and the Grenadines in 2008?
Provide a short and direct response. -9.23. What is the difference between the Expenses (% of total expenses) in Namibia in 2007 and the Expenses (% of total expenses) in St. Vincent and the Grenadines in 2008?
Provide a short and direct response. -1.06. What is the difference between the Expenses (% of total expenses) in Ghana in 2007 and the Expenses (% of total expenses) in Ireland in 2009?
Your answer should be compact. 4.08. What is the difference between the Expenses (% of total expenses) of Ghana in 2007 and the Expenses (% of total expenses) of Namibia in 2009?
Provide a short and direct response. -7.32. What is the difference between the Expenses (% of total expenses) of Ghana in 2007 and the Expenses (% of total expenses) of St. Vincent and the Grenadines in 2009?
Offer a terse response. -3.44. What is the difference between the Expenses (% of total expenses) of Ireland in 2007 and the Expenses (% of total expenses) of Namibia in 2009?
Offer a very short reply. -10.32. What is the difference between the Expenses (% of total expenses) of Ireland in 2007 and the Expenses (% of total expenses) of St. Vincent and the Grenadines in 2009?
Ensure brevity in your answer.  -6.44. What is the difference between the Expenses (% of total expenses) in Namibia in 2007 and the Expenses (% of total expenses) in St. Vincent and the Grenadines in 2009?
Ensure brevity in your answer.  1.73. What is the difference between the Expenses (% of total expenses) in Ghana in 2007 and the Expenses (% of total expenses) in Ireland in 2010?
Offer a very short reply. 7.71. What is the difference between the Expenses (% of total expenses) of Ghana in 2007 and the Expenses (% of total expenses) of Namibia in 2010?
Provide a short and direct response. -3.42. What is the difference between the Expenses (% of total expenses) in Ghana in 2007 and the Expenses (% of total expenses) in St. Vincent and the Grenadines in 2010?
Offer a very short reply. 0.71. What is the difference between the Expenses (% of total expenses) of Ireland in 2007 and the Expenses (% of total expenses) of Namibia in 2010?
Give a very brief answer. -6.42. What is the difference between the Expenses (% of total expenses) in Ireland in 2007 and the Expenses (% of total expenses) in St. Vincent and the Grenadines in 2010?
Provide a succinct answer. -2.29. What is the difference between the Expenses (% of total expenses) of Namibia in 2007 and the Expenses (% of total expenses) of St. Vincent and the Grenadines in 2010?
Your answer should be very brief. 5.88. What is the difference between the Expenses (% of total expenses) of Ghana in 2008 and the Expenses (% of total expenses) of Ireland in 2009?
Provide a short and direct response. 1.18. What is the difference between the Expenses (% of total expenses) of Ghana in 2008 and the Expenses (% of total expenses) of Namibia in 2009?
Offer a terse response. -10.21. What is the difference between the Expenses (% of total expenses) of Ghana in 2008 and the Expenses (% of total expenses) of St. Vincent and the Grenadines in 2009?
Provide a short and direct response. -6.33. What is the difference between the Expenses (% of total expenses) in Ireland in 2008 and the Expenses (% of total expenses) in Namibia in 2009?
Give a very brief answer. -11.01. What is the difference between the Expenses (% of total expenses) of Ireland in 2008 and the Expenses (% of total expenses) of St. Vincent and the Grenadines in 2009?
Your answer should be very brief. -7.13. What is the difference between the Expenses (% of total expenses) in Namibia in 2008 and the Expenses (% of total expenses) in St. Vincent and the Grenadines in 2009?
Keep it short and to the point. 3.24. What is the difference between the Expenses (% of total expenses) of Ghana in 2008 and the Expenses (% of total expenses) of Ireland in 2010?
Your response must be concise. 4.82. What is the difference between the Expenses (% of total expenses) of Ghana in 2008 and the Expenses (% of total expenses) of Namibia in 2010?
Your answer should be compact. -6.31. What is the difference between the Expenses (% of total expenses) in Ghana in 2008 and the Expenses (% of total expenses) in St. Vincent and the Grenadines in 2010?
Ensure brevity in your answer.  -2.18. What is the difference between the Expenses (% of total expenses) in Ireland in 2008 and the Expenses (% of total expenses) in Namibia in 2010?
Offer a very short reply. -7.11. What is the difference between the Expenses (% of total expenses) of Ireland in 2008 and the Expenses (% of total expenses) of St. Vincent and the Grenadines in 2010?
Your response must be concise. -2.98. What is the difference between the Expenses (% of total expenses) of Namibia in 2008 and the Expenses (% of total expenses) of St. Vincent and the Grenadines in 2010?
Keep it short and to the point. 7.39. What is the difference between the Expenses (% of total expenses) in Ghana in 2009 and the Expenses (% of total expenses) in Ireland in 2010?
Provide a succinct answer. 9.31. What is the difference between the Expenses (% of total expenses) in Ghana in 2009 and the Expenses (% of total expenses) in Namibia in 2010?
Give a very brief answer. -1.83. What is the difference between the Expenses (% of total expenses) of Ghana in 2009 and the Expenses (% of total expenses) of St. Vincent and the Grenadines in 2010?
Offer a very short reply. 2.3. What is the difference between the Expenses (% of total expenses) in Ireland in 2009 and the Expenses (% of total expenses) in Namibia in 2010?
Your response must be concise. -7.5. What is the difference between the Expenses (% of total expenses) of Ireland in 2009 and the Expenses (% of total expenses) of St. Vincent and the Grenadines in 2010?
Keep it short and to the point. -3.37. What is the difference between the Expenses (% of total expenses) in Namibia in 2009 and the Expenses (% of total expenses) in St. Vincent and the Grenadines in 2010?
Provide a succinct answer. 8.03. What is the average Expenses (% of total expenses) of Ghana per year?
Your response must be concise. 14.91. What is the average Expenses (% of total expenses) in Ireland per year?
Keep it short and to the point. 9.64. What is the average Expenses (% of total expenses) in Namibia per year?
Offer a very short reply. 18.79. What is the average Expenses (% of total expenses) in St. Vincent and the Grenadines per year?
Offer a terse response. 20.13. In the year 2003, what is the difference between the Expenses (% of total expenses) in Ghana and Expenses (% of total expenses) in Ireland?
Ensure brevity in your answer.  7.87. In the year 2003, what is the difference between the Expenses (% of total expenses) in Ghana and Expenses (% of total expenses) in Namibia?
Your answer should be compact. -4.65. In the year 2003, what is the difference between the Expenses (% of total expenses) in Ghana and Expenses (% of total expenses) in St. Vincent and the Grenadines?
Offer a very short reply. -7.1. In the year 2003, what is the difference between the Expenses (% of total expenses) in Ireland and Expenses (% of total expenses) in Namibia?
Offer a terse response. -12.51. In the year 2003, what is the difference between the Expenses (% of total expenses) of Ireland and Expenses (% of total expenses) of St. Vincent and the Grenadines?
Provide a short and direct response. -14.96. In the year 2003, what is the difference between the Expenses (% of total expenses) of Namibia and Expenses (% of total expenses) of St. Vincent and the Grenadines?
Make the answer very short. -2.45. In the year 2004, what is the difference between the Expenses (% of total expenses) of Ghana and Expenses (% of total expenses) of Ireland?
Ensure brevity in your answer.  6.65. In the year 2004, what is the difference between the Expenses (% of total expenses) of Ghana and Expenses (% of total expenses) of Namibia?
Ensure brevity in your answer.  -3.45. In the year 2004, what is the difference between the Expenses (% of total expenses) of Ghana and Expenses (% of total expenses) of St. Vincent and the Grenadines?
Provide a short and direct response. -9.99. In the year 2004, what is the difference between the Expenses (% of total expenses) of Ireland and Expenses (% of total expenses) of Namibia?
Your response must be concise. -10.1. In the year 2004, what is the difference between the Expenses (% of total expenses) in Ireland and Expenses (% of total expenses) in St. Vincent and the Grenadines?
Keep it short and to the point. -16.64. In the year 2004, what is the difference between the Expenses (% of total expenses) of Namibia and Expenses (% of total expenses) of St. Vincent and the Grenadines?
Keep it short and to the point. -6.53. In the year 2005, what is the difference between the Expenses (% of total expenses) in Ghana and Expenses (% of total expenses) in Ireland?
Make the answer very short. 6.51. In the year 2005, what is the difference between the Expenses (% of total expenses) in Ghana and Expenses (% of total expenses) in Namibia?
Your response must be concise. 1.89. In the year 2005, what is the difference between the Expenses (% of total expenses) in Ghana and Expenses (% of total expenses) in St. Vincent and the Grenadines?
Give a very brief answer. -3.31. In the year 2005, what is the difference between the Expenses (% of total expenses) in Ireland and Expenses (% of total expenses) in Namibia?
Keep it short and to the point. -4.62. In the year 2005, what is the difference between the Expenses (% of total expenses) of Ireland and Expenses (% of total expenses) of St. Vincent and the Grenadines?
Make the answer very short. -9.82. In the year 2005, what is the difference between the Expenses (% of total expenses) in Namibia and Expenses (% of total expenses) in St. Vincent and the Grenadines?
Make the answer very short. -5.2. In the year 2006, what is the difference between the Expenses (% of total expenses) of Ghana and Expenses (% of total expenses) of Ireland?
Provide a short and direct response. 4.03. In the year 2006, what is the difference between the Expenses (% of total expenses) in Ghana and Expenses (% of total expenses) in Namibia?
Make the answer very short. -0.87. In the year 2006, what is the difference between the Expenses (% of total expenses) of Ghana and Expenses (% of total expenses) of St. Vincent and the Grenadines?
Keep it short and to the point. -6.15. In the year 2006, what is the difference between the Expenses (% of total expenses) in Ireland and Expenses (% of total expenses) in Namibia?
Keep it short and to the point. -4.9. In the year 2006, what is the difference between the Expenses (% of total expenses) of Ireland and Expenses (% of total expenses) of St. Vincent and the Grenadines?
Give a very brief answer. -10.18. In the year 2006, what is the difference between the Expenses (% of total expenses) of Namibia and Expenses (% of total expenses) of St. Vincent and the Grenadines?
Ensure brevity in your answer.  -5.28. In the year 2007, what is the difference between the Expenses (% of total expenses) in Ghana and Expenses (% of total expenses) in Ireland?
Your answer should be very brief. 3. In the year 2007, what is the difference between the Expenses (% of total expenses) of Ghana and Expenses (% of total expenses) of Namibia?
Your response must be concise. -5.17. In the year 2007, what is the difference between the Expenses (% of total expenses) of Ghana and Expenses (% of total expenses) of St. Vincent and the Grenadines?
Provide a succinct answer. -4.83. In the year 2007, what is the difference between the Expenses (% of total expenses) of Ireland and Expenses (% of total expenses) of Namibia?
Offer a terse response. -8.17. In the year 2007, what is the difference between the Expenses (% of total expenses) in Ireland and Expenses (% of total expenses) in St. Vincent and the Grenadines?
Provide a succinct answer. -7.83. In the year 2007, what is the difference between the Expenses (% of total expenses) of Namibia and Expenses (% of total expenses) of St. Vincent and the Grenadines?
Provide a succinct answer. 0.34. In the year 2008, what is the difference between the Expenses (% of total expenses) in Ghana and Expenses (% of total expenses) in Ireland?
Keep it short and to the point. 0.79. In the year 2008, what is the difference between the Expenses (% of total expenses) in Ghana and Expenses (% of total expenses) in Namibia?
Provide a succinct answer. -9.57. In the year 2008, what is the difference between the Expenses (% of total expenses) of Ghana and Expenses (% of total expenses) of St. Vincent and the Grenadines?
Your answer should be very brief. -9.13. In the year 2008, what is the difference between the Expenses (% of total expenses) in Ireland and Expenses (% of total expenses) in Namibia?
Ensure brevity in your answer.  -10.37. In the year 2008, what is the difference between the Expenses (% of total expenses) of Ireland and Expenses (% of total expenses) of St. Vincent and the Grenadines?
Provide a short and direct response. -9.92. In the year 2008, what is the difference between the Expenses (% of total expenses) in Namibia and Expenses (% of total expenses) in St. Vincent and the Grenadines?
Give a very brief answer. 0.44. In the year 2009, what is the difference between the Expenses (% of total expenses) of Ghana and Expenses (% of total expenses) of Ireland?
Offer a terse response. 5.67. In the year 2009, what is the difference between the Expenses (% of total expenses) of Ghana and Expenses (% of total expenses) of Namibia?
Your answer should be compact. -5.72. In the year 2009, what is the difference between the Expenses (% of total expenses) in Ghana and Expenses (% of total expenses) in St. Vincent and the Grenadines?
Give a very brief answer. -1.84. In the year 2009, what is the difference between the Expenses (% of total expenses) of Ireland and Expenses (% of total expenses) of Namibia?
Provide a succinct answer. -11.39. In the year 2009, what is the difference between the Expenses (% of total expenses) in Ireland and Expenses (% of total expenses) in St. Vincent and the Grenadines?
Your answer should be very brief. -7.51. In the year 2009, what is the difference between the Expenses (% of total expenses) of Namibia and Expenses (% of total expenses) of St. Vincent and the Grenadines?
Your answer should be very brief. 3.88. In the year 2010, what is the difference between the Expenses (% of total expenses) of Ghana and Expenses (% of total expenses) of Ireland?
Ensure brevity in your answer.  7.6. In the year 2010, what is the difference between the Expenses (% of total expenses) in Ghana and Expenses (% of total expenses) in Namibia?
Your answer should be very brief. -3.53. In the year 2010, what is the difference between the Expenses (% of total expenses) in Ghana and Expenses (% of total expenses) in St. Vincent and the Grenadines?
Ensure brevity in your answer.  0.6. In the year 2010, what is the difference between the Expenses (% of total expenses) of Ireland and Expenses (% of total expenses) of Namibia?
Offer a very short reply. -11.13. In the year 2010, what is the difference between the Expenses (% of total expenses) of Ireland and Expenses (% of total expenses) of St. Vincent and the Grenadines?
Your response must be concise. -7. In the year 2010, what is the difference between the Expenses (% of total expenses) in Namibia and Expenses (% of total expenses) in St. Vincent and the Grenadines?
Provide a succinct answer. 4.13. What is the ratio of the Expenses (% of total expenses) in Ghana in 2003 to that in 2004?
Provide a succinct answer. 1.08. What is the ratio of the Expenses (% of total expenses) of Namibia in 2003 to that in 2004?
Make the answer very short. 1.13. What is the ratio of the Expenses (% of total expenses) of St. Vincent and the Grenadines in 2003 to that in 2004?
Offer a very short reply. 0.92. What is the ratio of the Expenses (% of total expenses) of Ghana in 2003 to that in 2005?
Provide a short and direct response. 0.78. What is the ratio of the Expenses (% of total expenses) in Ireland in 2003 to that in 2005?
Your answer should be very brief. 0.54. What is the ratio of the Expenses (% of total expenses) of Namibia in 2003 to that in 2005?
Your response must be concise. 1.15. What is the ratio of the Expenses (% of total expenses) in Ghana in 2003 to that in 2006?
Provide a short and direct response. 0.9. What is the ratio of the Expenses (% of total expenses) in Ireland in 2003 to that in 2006?
Offer a terse response. 0.54. What is the ratio of the Expenses (% of total expenses) in Namibia in 2003 to that in 2006?
Ensure brevity in your answer.  1.14. What is the ratio of the Expenses (% of total expenses) of St. Vincent and the Grenadines in 2003 to that in 2006?
Keep it short and to the point. 0.97. What is the ratio of the Expenses (% of total expenses) of Ghana in 2003 to that in 2007?
Your answer should be very brief. 0.95. What is the ratio of the Expenses (% of total expenses) of Ireland in 2003 to that in 2007?
Your response must be concise. 0.53. What is the ratio of the Expenses (% of total expenses) in Namibia in 2003 to that in 2007?
Give a very brief answer. 0.94. What is the ratio of the Expenses (% of total expenses) of St. Vincent and the Grenadines in 2003 to that in 2007?
Ensure brevity in your answer.  1.08. What is the ratio of the Expenses (% of total expenses) of Ghana in 2003 to that in 2008?
Give a very brief answer. 1.18. What is the ratio of the Expenses (% of total expenses) in Ireland in 2003 to that in 2008?
Your answer should be compact. 0.56. What is the ratio of the Expenses (% of total expenses) of Namibia in 2003 to that in 2008?
Ensure brevity in your answer.  0.87. What is the ratio of the Expenses (% of total expenses) of St. Vincent and the Grenadines in 2003 to that in 2008?
Provide a succinct answer. 1.01. What is the ratio of the Expenses (% of total expenses) of Ghana in 2003 to that in 2009?
Your answer should be compact. 0.86. What is the ratio of the Expenses (% of total expenses) of Ireland in 2003 to that in 2009?
Ensure brevity in your answer.  0.58. What is the ratio of the Expenses (% of total expenses) in Namibia in 2003 to that in 2009?
Your response must be concise. 0.85. What is the ratio of the Expenses (% of total expenses) of St. Vincent and the Grenadines in 2003 to that in 2009?
Provide a short and direct response. 1.16. What is the ratio of the Expenses (% of total expenses) of Ghana in 2003 to that in 2010?
Your response must be concise. 0.96. What is the ratio of the Expenses (% of total expenses) of Ireland in 2003 to that in 2010?
Provide a short and direct response. 0.88. What is the ratio of the Expenses (% of total expenses) of Namibia in 2003 to that in 2010?
Offer a very short reply. 1.03. What is the ratio of the Expenses (% of total expenses) of St. Vincent and the Grenadines in 2003 to that in 2010?
Make the answer very short. 1.5. What is the ratio of the Expenses (% of total expenses) of Ghana in 2004 to that in 2005?
Give a very brief answer. 0.72. What is the ratio of the Expenses (% of total expenses) of Ireland in 2004 to that in 2005?
Offer a very short reply. 0.56. What is the ratio of the Expenses (% of total expenses) in Namibia in 2004 to that in 2005?
Ensure brevity in your answer.  1.02. What is the ratio of the Expenses (% of total expenses) in St. Vincent and the Grenadines in 2004 to that in 2005?
Ensure brevity in your answer.  1.08. What is the ratio of the Expenses (% of total expenses) of Ghana in 2004 to that in 2006?
Make the answer very short. 0.84. What is the ratio of the Expenses (% of total expenses) of Ireland in 2004 to that in 2006?
Ensure brevity in your answer.  0.56. What is the ratio of the Expenses (% of total expenses) of St. Vincent and the Grenadines in 2004 to that in 2006?
Provide a short and direct response. 1.06. What is the ratio of the Expenses (% of total expenses) in Ghana in 2004 to that in 2007?
Provide a short and direct response. 0.88. What is the ratio of the Expenses (% of total expenses) of Ireland in 2004 to that in 2007?
Your response must be concise. 0.54. What is the ratio of the Expenses (% of total expenses) of Namibia in 2004 to that in 2007?
Provide a succinct answer. 0.83. What is the ratio of the Expenses (% of total expenses) of St. Vincent and the Grenadines in 2004 to that in 2007?
Ensure brevity in your answer.  1.17. What is the ratio of the Expenses (% of total expenses) in Ghana in 2004 to that in 2008?
Offer a very short reply. 1.09. What is the ratio of the Expenses (% of total expenses) in Ireland in 2004 to that in 2008?
Give a very brief answer. 0.58. What is the ratio of the Expenses (% of total expenses) of Namibia in 2004 to that in 2008?
Give a very brief answer. 0.77. What is the ratio of the Expenses (% of total expenses) in St. Vincent and the Grenadines in 2004 to that in 2008?
Offer a very short reply. 1.09. What is the ratio of the Expenses (% of total expenses) in Ghana in 2004 to that in 2009?
Keep it short and to the point. 0.8. What is the ratio of the Expenses (% of total expenses) of Ireland in 2004 to that in 2009?
Provide a short and direct response. 0.6. What is the ratio of the Expenses (% of total expenses) in Namibia in 2004 to that in 2009?
Keep it short and to the point. 0.75. What is the ratio of the Expenses (% of total expenses) of St. Vincent and the Grenadines in 2004 to that in 2009?
Your response must be concise. 1.26. What is the ratio of the Expenses (% of total expenses) of Ghana in 2004 to that in 2010?
Make the answer very short. 0.89. What is the ratio of the Expenses (% of total expenses) in Ireland in 2004 to that in 2010?
Provide a short and direct response. 0.9. What is the ratio of the Expenses (% of total expenses) in Namibia in 2004 to that in 2010?
Your answer should be very brief. 0.91. What is the ratio of the Expenses (% of total expenses) in St. Vincent and the Grenadines in 2004 to that in 2010?
Make the answer very short. 1.63. What is the ratio of the Expenses (% of total expenses) of Ghana in 2005 to that in 2006?
Give a very brief answer. 1.16. What is the ratio of the Expenses (% of total expenses) of Ireland in 2005 to that in 2006?
Your answer should be very brief. 1. What is the ratio of the Expenses (% of total expenses) in Namibia in 2005 to that in 2006?
Provide a succinct answer. 0.99. What is the ratio of the Expenses (% of total expenses) in St. Vincent and the Grenadines in 2005 to that in 2006?
Make the answer very short. 0.99. What is the ratio of the Expenses (% of total expenses) of Ghana in 2005 to that in 2007?
Provide a short and direct response. 1.22. What is the ratio of the Expenses (% of total expenses) of Ireland in 2005 to that in 2007?
Provide a succinct answer. 0.98. What is the ratio of the Expenses (% of total expenses) in Namibia in 2005 to that in 2007?
Provide a succinct answer. 0.81. What is the ratio of the Expenses (% of total expenses) in St. Vincent and the Grenadines in 2005 to that in 2007?
Your response must be concise. 1.09. What is the ratio of the Expenses (% of total expenses) in Ghana in 2005 to that in 2008?
Give a very brief answer. 1.52. What is the ratio of the Expenses (% of total expenses) of Ireland in 2005 to that in 2008?
Your response must be concise. 1.04. What is the ratio of the Expenses (% of total expenses) of Namibia in 2005 to that in 2008?
Provide a succinct answer. 0.76. What is the ratio of the Expenses (% of total expenses) in St. Vincent and the Grenadines in 2005 to that in 2008?
Make the answer very short. 1.02. What is the ratio of the Expenses (% of total expenses) of Ghana in 2005 to that in 2009?
Ensure brevity in your answer.  1.1. What is the ratio of the Expenses (% of total expenses) in Ireland in 2005 to that in 2009?
Your answer should be compact. 1.08. What is the ratio of the Expenses (% of total expenses) in Namibia in 2005 to that in 2009?
Give a very brief answer. 0.73. What is the ratio of the Expenses (% of total expenses) of St. Vincent and the Grenadines in 2005 to that in 2009?
Your response must be concise. 1.17. What is the ratio of the Expenses (% of total expenses) in Ghana in 2005 to that in 2010?
Your response must be concise. 1.23. What is the ratio of the Expenses (% of total expenses) in Ireland in 2005 to that in 2010?
Make the answer very short. 1.63. What is the ratio of the Expenses (% of total expenses) in Namibia in 2005 to that in 2010?
Provide a succinct answer. 0.89. What is the ratio of the Expenses (% of total expenses) of St. Vincent and the Grenadines in 2005 to that in 2010?
Your answer should be compact. 1.52. What is the ratio of the Expenses (% of total expenses) in Ghana in 2006 to that in 2007?
Your response must be concise. 1.05. What is the ratio of the Expenses (% of total expenses) in Ireland in 2006 to that in 2007?
Ensure brevity in your answer.  0.98. What is the ratio of the Expenses (% of total expenses) of Namibia in 2006 to that in 2007?
Your answer should be compact. 0.82. What is the ratio of the Expenses (% of total expenses) in St. Vincent and the Grenadines in 2006 to that in 2007?
Give a very brief answer. 1.11. What is the ratio of the Expenses (% of total expenses) in Ghana in 2006 to that in 2008?
Your response must be concise. 1.3. What is the ratio of the Expenses (% of total expenses) in Ireland in 2006 to that in 2008?
Offer a terse response. 1.04. What is the ratio of the Expenses (% of total expenses) of Namibia in 2006 to that in 2008?
Give a very brief answer. 0.77. What is the ratio of the Expenses (% of total expenses) of St. Vincent and the Grenadines in 2006 to that in 2008?
Your response must be concise. 1.03. What is the ratio of the Expenses (% of total expenses) of Ghana in 2006 to that in 2009?
Provide a short and direct response. 0.95. What is the ratio of the Expenses (% of total expenses) in Ireland in 2006 to that in 2009?
Keep it short and to the point. 1.07. What is the ratio of the Expenses (% of total expenses) of Namibia in 2006 to that in 2009?
Offer a very short reply. 0.74. What is the ratio of the Expenses (% of total expenses) of St. Vincent and the Grenadines in 2006 to that in 2009?
Offer a very short reply. 1.19. What is the ratio of the Expenses (% of total expenses) of Ghana in 2006 to that in 2010?
Offer a terse response. 1.06. What is the ratio of the Expenses (% of total expenses) in Ireland in 2006 to that in 2010?
Your response must be concise. 1.62. What is the ratio of the Expenses (% of total expenses) of Namibia in 2006 to that in 2010?
Your answer should be very brief. 0.9. What is the ratio of the Expenses (% of total expenses) in St. Vincent and the Grenadines in 2006 to that in 2010?
Your answer should be compact. 1.54. What is the ratio of the Expenses (% of total expenses) of Ghana in 2007 to that in 2008?
Keep it short and to the point. 1.24. What is the ratio of the Expenses (% of total expenses) of Ireland in 2007 to that in 2008?
Keep it short and to the point. 1.06. What is the ratio of the Expenses (% of total expenses) of Namibia in 2007 to that in 2008?
Your response must be concise. 0.93. What is the ratio of the Expenses (% of total expenses) of St. Vincent and the Grenadines in 2007 to that in 2008?
Ensure brevity in your answer.  0.93. What is the ratio of the Expenses (% of total expenses) of Ghana in 2007 to that in 2009?
Provide a short and direct response. 0.9. What is the ratio of the Expenses (% of total expenses) of Ireland in 2007 to that in 2009?
Provide a short and direct response. 1.1. What is the ratio of the Expenses (% of total expenses) of Namibia in 2007 to that in 2009?
Your response must be concise. 0.9. What is the ratio of the Expenses (% of total expenses) of St. Vincent and the Grenadines in 2007 to that in 2009?
Ensure brevity in your answer.  1.08. What is the ratio of the Expenses (% of total expenses) in Ghana in 2007 to that in 2010?
Ensure brevity in your answer.  1.01. What is the ratio of the Expenses (% of total expenses) in Ireland in 2007 to that in 2010?
Give a very brief answer. 1.66. What is the ratio of the Expenses (% of total expenses) of Namibia in 2007 to that in 2010?
Give a very brief answer. 1.1. What is the ratio of the Expenses (% of total expenses) in St. Vincent and the Grenadines in 2007 to that in 2010?
Offer a terse response. 1.39. What is the ratio of the Expenses (% of total expenses) in Ghana in 2008 to that in 2009?
Keep it short and to the point. 0.73. What is the ratio of the Expenses (% of total expenses) in Ireland in 2008 to that in 2009?
Your answer should be compact. 1.04. What is the ratio of the Expenses (% of total expenses) in Namibia in 2008 to that in 2009?
Your answer should be very brief. 0.97. What is the ratio of the Expenses (% of total expenses) in St. Vincent and the Grenadines in 2008 to that in 2009?
Provide a short and direct response. 1.15. What is the ratio of the Expenses (% of total expenses) of Ghana in 2008 to that in 2010?
Your answer should be very brief. 0.81. What is the ratio of the Expenses (% of total expenses) of Ireland in 2008 to that in 2010?
Your answer should be compact. 1.56. What is the ratio of the Expenses (% of total expenses) of Namibia in 2008 to that in 2010?
Offer a very short reply. 1.18. What is the ratio of the Expenses (% of total expenses) of St. Vincent and the Grenadines in 2008 to that in 2010?
Offer a terse response. 1.49. What is the ratio of the Expenses (% of total expenses) in Ghana in 2009 to that in 2010?
Your response must be concise. 1.12. What is the ratio of the Expenses (% of total expenses) in Ireland in 2009 to that in 2010?
Your response must be concise. 1.51. What is the ratio of the Expenses (% of total expenses) of Namibia in 2009 to that in 2010?
Ensure brevity in your answer.  1.21. What is the ratio of the Expenses (% of total expenses) in St. Vincent and the Grenadines in 2009 to that in 2010?
Provide a succinct answer. 1.29. What is the difference between the highest and the second highest Expenses (% of total expenses) of Ghana?
Your answer should be very brief. 1.7. What is the difference between the highest and the second highest Expenses (% of total expenses) in Ireland?
Provide a short and direct response. 0.22. What is the difference between the highest and the second highest Expenses (% of total expenses) in Namibia?
Provide a succinct answer. 0.64. What is the difference between the highest and the second highest Expenses (% of total expenses) of St. Vincent and the Grenadines?
Offer a terse response. 1.32. What is the difference between the highest and the lowest Expenses (% of total expenses) in Ghana?
Offer a terse response. 6.19. What is the difference between the highest and the lowest Expenses (% of total expenses) of Ireland?
Your answer should be compact. 5.61. What is the difference between the highest and the lowest Expenses (% of total expenses) of Namibia?
Provide a succinct answer. 5.92. What is the difference between the highest and the lowest Expenses (% of total expenses) in St. Vincent and the Grenadines?
Ensure brevity in your answer.  8.94. 